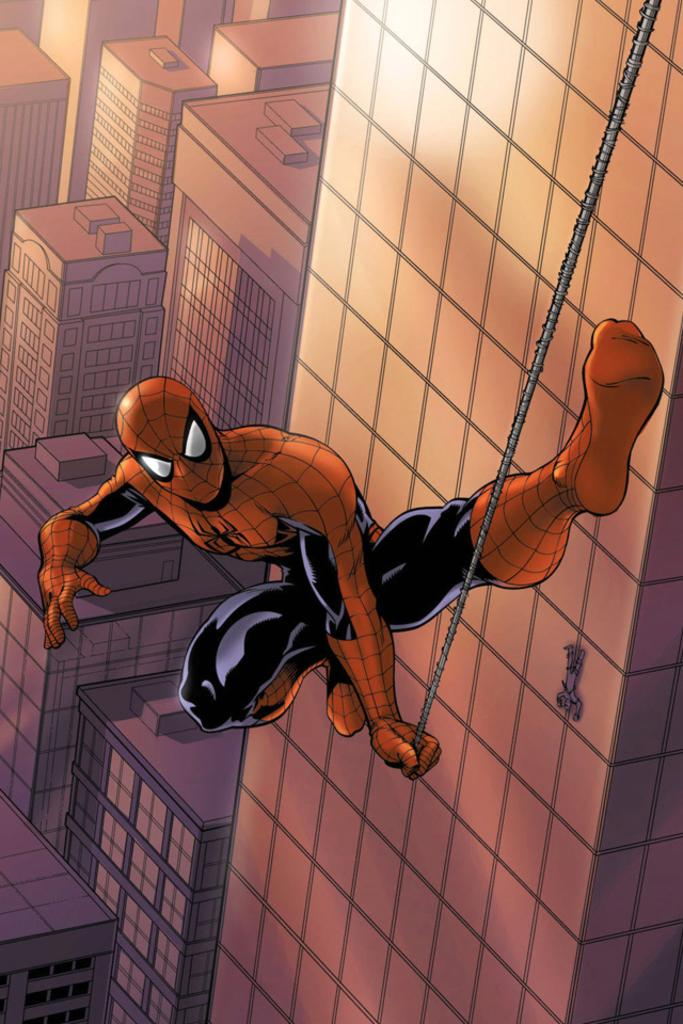What type of image is being described? The image is animated. Who is the main character in the image? There is a Spider-Man character in the image. What is Spider-Man holding in the image? Spider-Man is holding a rope. What can be seen in the background of the image? There are buildings visible in the background of the image. What type of mitten is Spider-Man wearing in the image? Spider-Man is not wearing a mitten in the image; he is wearing his iconic Spider-Man suit. How does Spider-Man make his payment for the rope in the image? There is no indication of payment in the image; Spider-Man is simply holding a rope. 